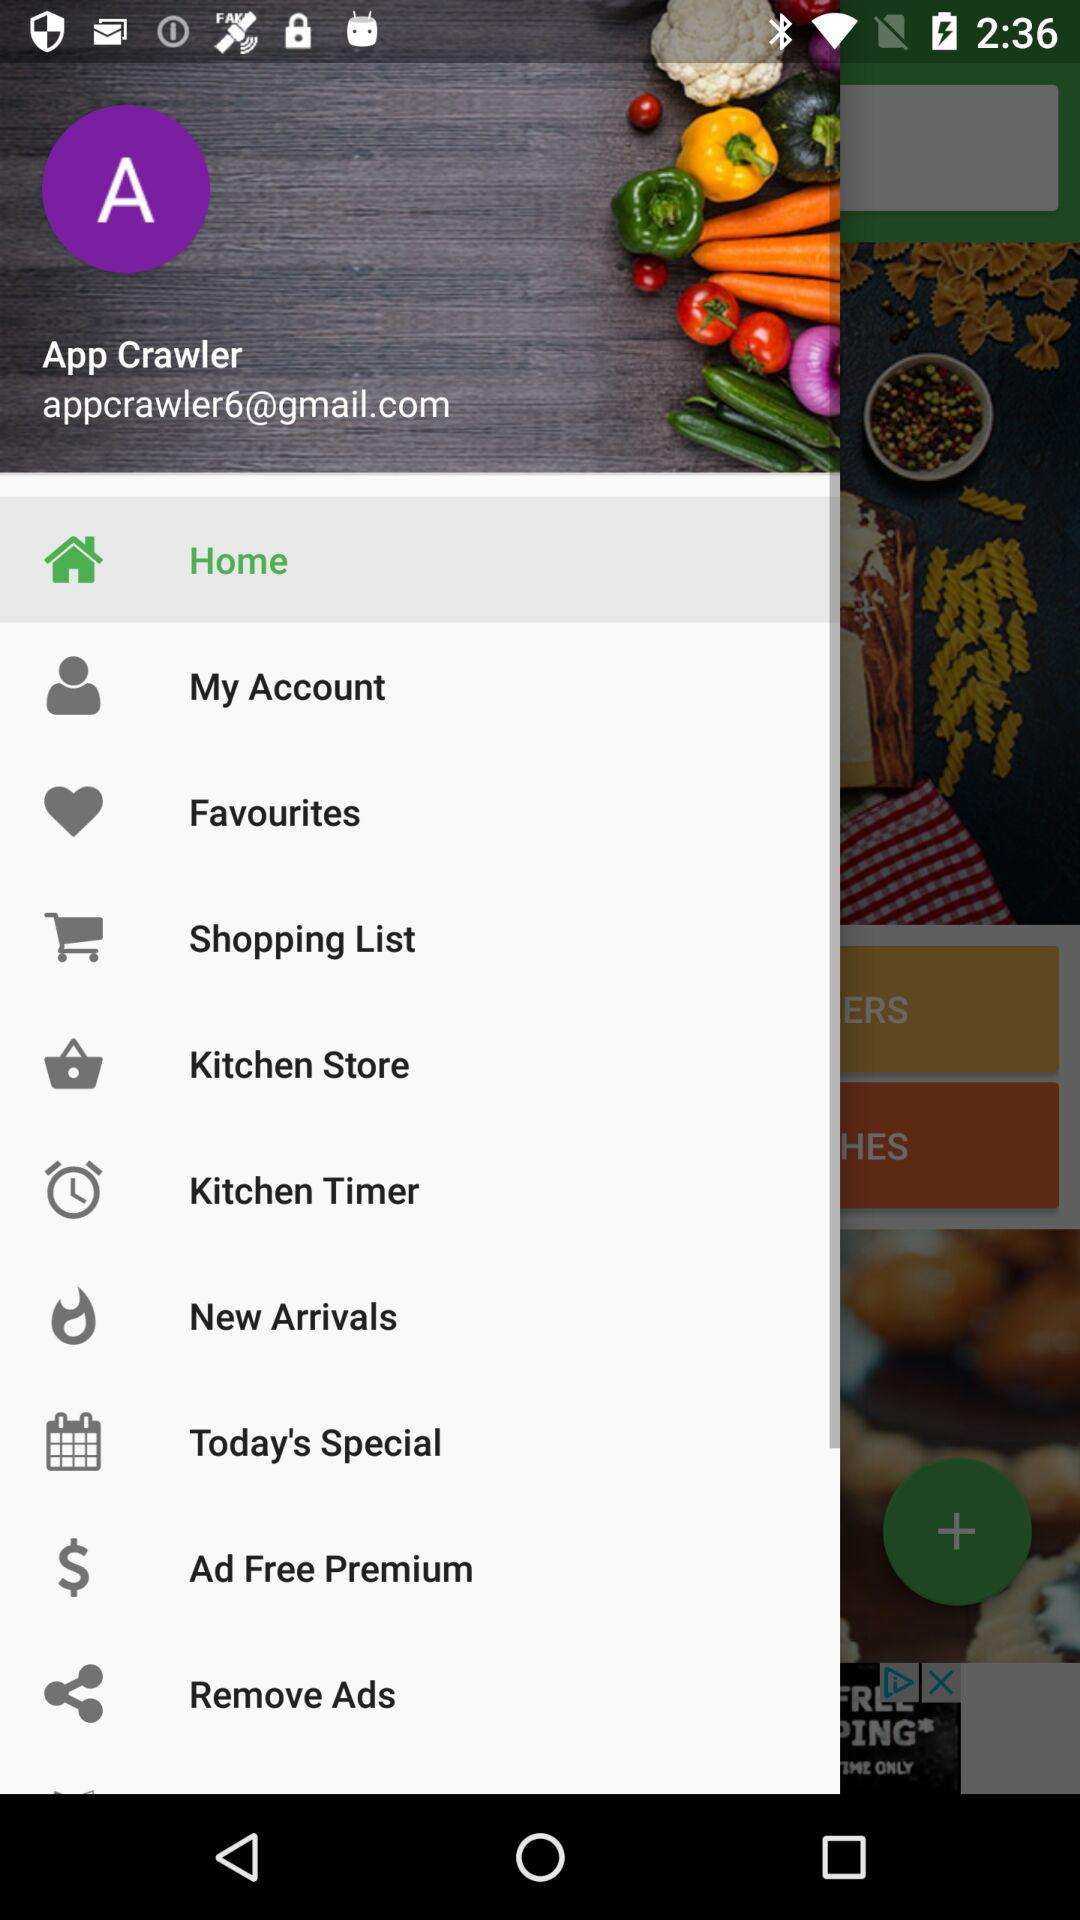What is the email address? The email address is appcrawler6@gmail.com. 